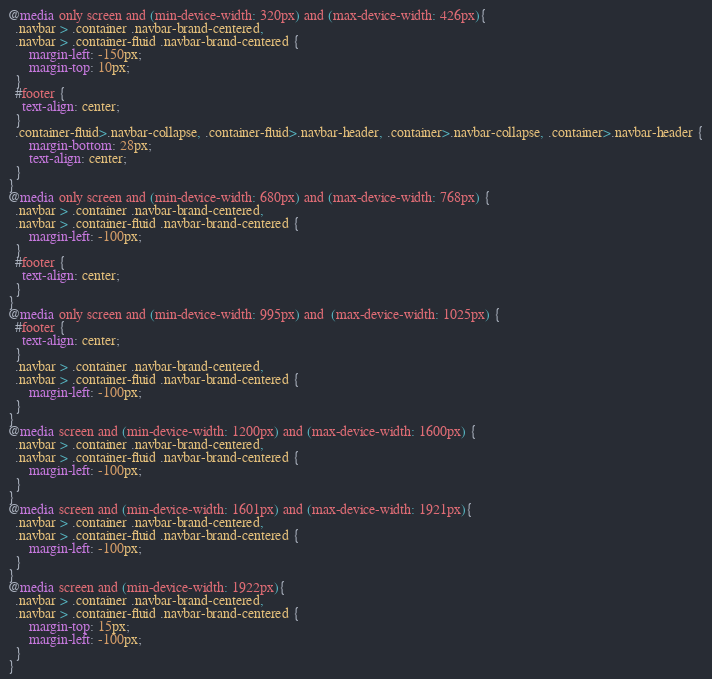<code> <loc_0><loc_0><loc_500><loc_500><_CSS_>@media only screen and (min-device-width: 320px) and (max-device-width: 426px){
  .navbar > .container .navbar-brand-centered,
  .navbar > .container-fluid .navbar-brand-centered {
      margin-left: -150px;
      margin-top: 10px;
  }
  #footer {
    text-align: center;
  }
  .container-fluid>.navbar-collapse, .container-fluid>.navbar-header, .container>.navbar-collapse, .container>.navbar-header {
      margin-bottom: 28px;
      text-align: center;
  }
}
@media only screen and (min-device-width: 680px) and (max-device-width: 768px) {
  .navbar > .container .navbar-brand-centered,
  .navbar > .container-fluid .navbar-brand-centered {
      margin-left: -100px;
  }
  #footer {
    text-align: center;
  }
}
@media only screen and (min-device-width: 995px) and  (max-device-width: 1025px) {
  #footer {
    text-align: center;
  }
  .navbar > .container .navbar-brand-centered,
  .navbar > .container-fluid .navbar-brand-centered {
      margin-left: -100px;
  }
}
@media screen and (min-device-width: 1200px) and (max-device-width: 1600px) {
  .navbar > .container .navbar-brand-centered,
  .navbar > .container-fluid .navbar-brand-centered {
      margin-left: -100px;
  }
}
@media screen and (min-device-width: 1601px) and (max-device-width: 1921px){
  .navbar > .container .navbar-brand-centered,
  .navbar > .container-fluid .navbar-brand-centered {
      margin-left: -100px;
  }
}
@media screen and (min-device-width: 1922px){
  .navbar > .container .navbar-brand-centered,
  .navbar > .container-fluid .navbar-brand-centered {
      margin-top: 15px;
      margin-left: -100px;
  }
}
</code> 